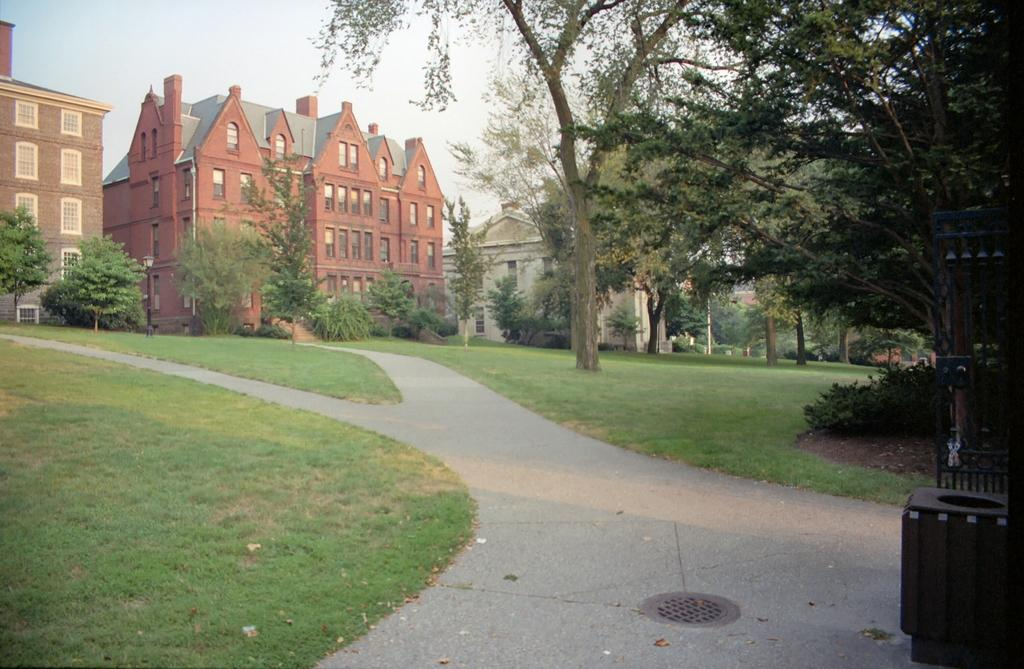What type of structures can be seen in the image? There are buildings in the image. What natural elements are present in the image? There are trees, grass, and plants in the image. What man-made feature is visible in the image? There is a road in the image. What part of the natural environment is visible in the image? The sky is visible in the image. What story is being told by the plants in the image? There is no story being told by the plants in the image; they are simply part of the natural environment. Can you describe the slope of the road in the image? There is no mention of a slope in the image; the road appears to be flat. 